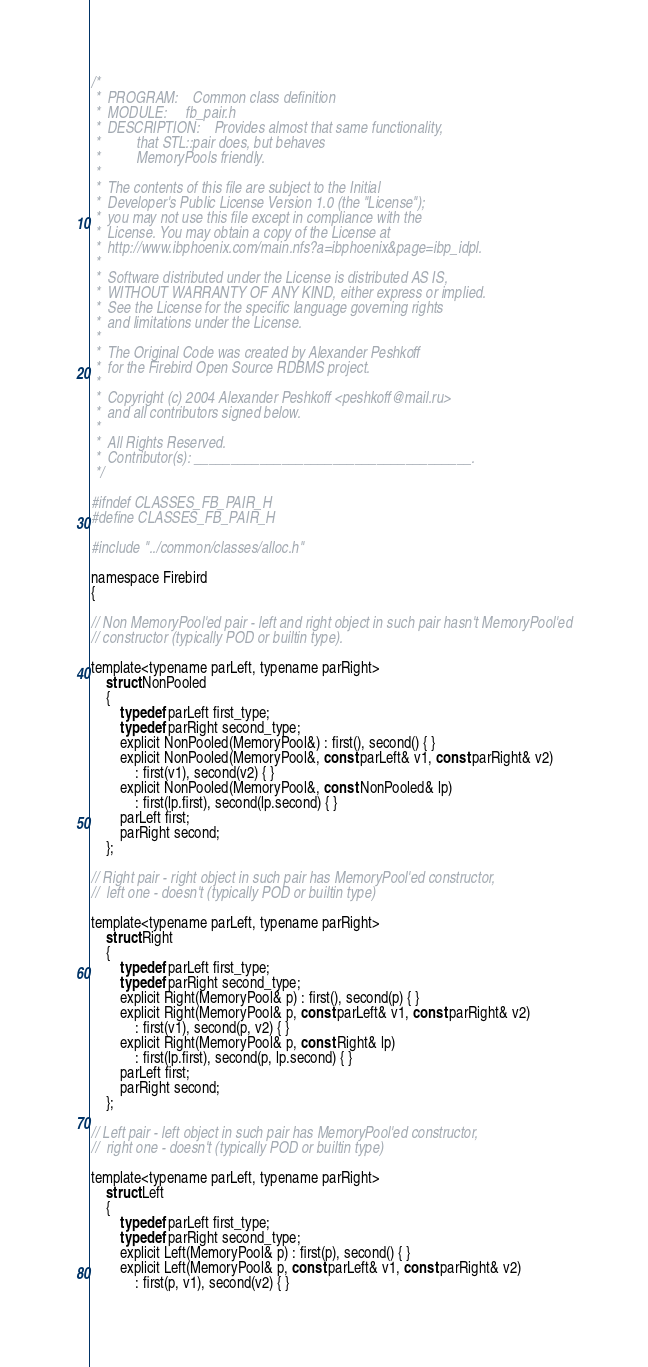<code> <loc_0><loc_0><loc_500><loc_500><_C_>/*
 *	PROGRAM:	Common class definition
 *	MODULE:		fb_pair.h
 *	DESCRIPTION:	Provides almost that same functionality,
 *			that STL::pair does, but behaves
 *			MemoryPools friendly.
 *
 *  The contents of this file are subject to the Initial
 *  Developer's Public License Version 1.0 (the "License");
 *  you may not use this file except in compliance with the
 *  License. You may obtain a copy of the License at
 *  http://www.ibphoenix.com/main.nfs?a=ibphoenix&page=ibp_idpl.
 *
 *  Software distributed under the License is distributed AS IS,
 *  WITHOUT WARRANTY OF ANY KIND, either express or implied.
 *  See the License for the specific language governing rights
 *  and limitations under the License.
 *
 *  The Original Code was created by Alexander Peshkoff
 *  for the Firebird Open Source RDBMS project.
 *
 *  Copyright (c) 2004 Alexander Peshkoff <peshkoff@mail.ru>
 *  and all contributors signed below.
 *
 *  All Rights Reserved.
 *  Contributor(s): ______________________________________.
 */

#ifndef CLASSES_FB_PAIR_H
#define CLASSES_FB_PAIR_H

#include "../common/classes/alloc.h"

namespace Firebird
{

// Non MemoryPool'ed pair - left and right object in such pair hasn't MemoryPool'ed
// constructor (typically POD or builtin type).

template<typename parLeft, typename parRight>
	struct NonPooled
	{
		typedef parLeft first_type;
		typedef parRight second_type;
		explicit NonPooled(MemoryPool&) : first(), second() { }
		explicit NonPooled(MemoryPool&, const parLeft& v1, const parRight& v2)
			: first(v1), second(v2) { }
		explicit NonPooled(MemoryPool&, const NonPooled& lp)
			: first(lp.first), second(lp.second) { }
		parLeft first;
		parRight second;
	};

// Right pair - right object in such pair has MemoryPool'ed constructor,
//	left one - doesn't (typically POD or builtin type)

template<typename parLeft, typename parRight>
	struct Right
	{
		typedef parLeft first_type;
		typedef parRight second_type;
		explicit Right(MemoryPool& p) : first(), second(p) { }
		explicit Right(MemoryPool& p, const parLeft& v1, const parRight& v2)
			: first(v1), second(p, v2) { }
		explicit Right(MemoryPool& p, const Right& lp)
			: first(lp.first), second(p, lp.second) { }
		parLeft first;
		parRight second;
	};

// Left pair - left object in such pair has MemoryPool'ed constructor,
//	right one - doesn't (typically POD or builtin type)

template<typename parLeft, typename parRight>
	struct Left
	{
		typedef parLeft first_type;
		typedef parRight second_type;
		explicit Left(MemoryPool& p) : first(p), second() { }
		explicit Left(MemoryPool& p, const parLeft& v1, const parRight& v2)
			: first(p, v1), second(v2) { }</code> 